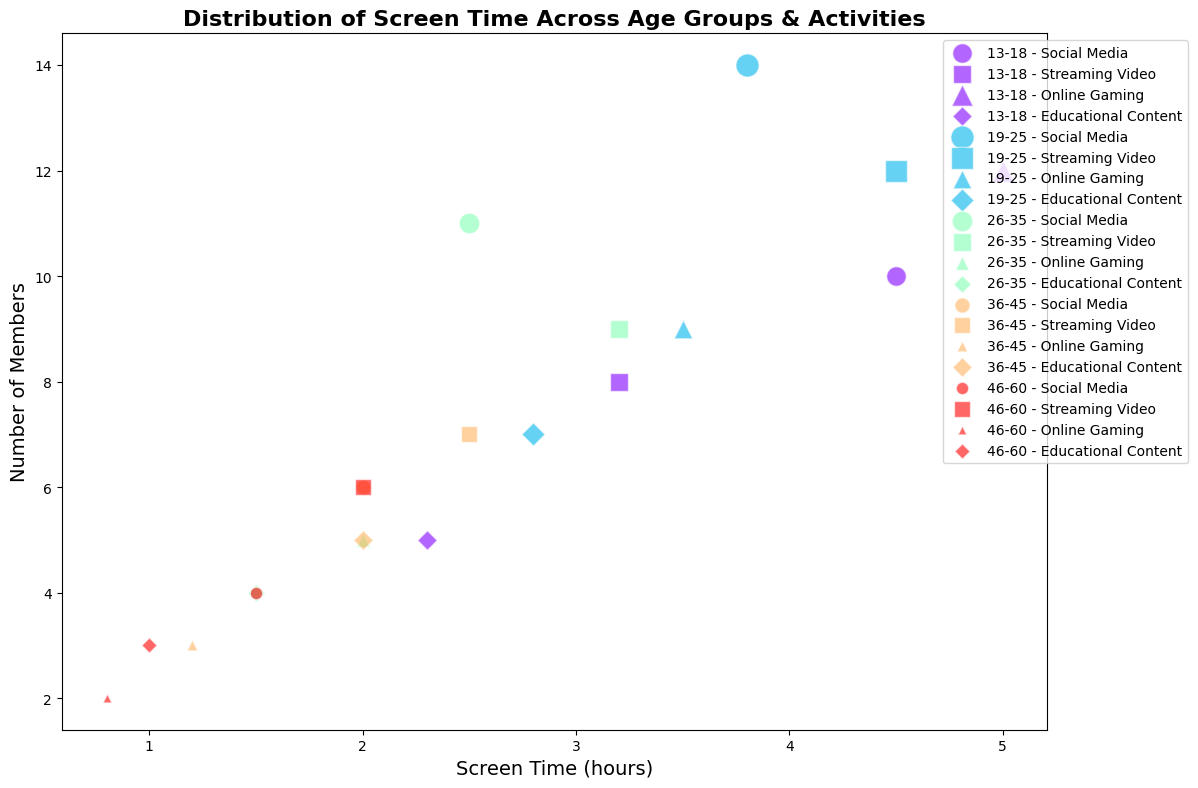What's the average screen time for Online Gaming across all age groups? To calculate the average screen time, sum the screen times for Online Gaming in each age group (5.0 + 3.5 + 2.0 + 1.2 + 0.8) and divide by the number of groups (5). This gives (5.0 + 3.5 + 2.0 + 1.2 + 0.8) / 5 = 12.5 / 5 = 2.5 hours.
Answer: 2.5 hours Which age group has the highest number of members engaged in Social Media? Compare the sizes of bubbles representing Social Media across all age groups. The 19-25 age group has the largest bubble, indicating the highest number of members (14).
Answer: 19-25 Is the screen time for Educational Content higher for the 13-18 age group or the 26-35 age group? Compare the position of the bubbles on the x-axis for Educational Content between the 13-18 and 26-35 age groups. The 13-18 age group has a bubble positioned at 2.3 hours, while the 26-35 age group has a bubble at 1.5 hours.
Answer: 13-18 Which activity has the greatest screen time for the 46-60 age group? Check the x-axis positions of all activities for the 46-60 age group. Streaming Video has the highest value at 2.0 hours.
Answer: Streaming Video In the 36-45 age group, how much greater is the screen time for Streaming Video compared to Online Gaming? Calculate the difference between the screen times for Streaming Video (2.5 hours) and Online Gaming (1.2 hours) for the 36-45 age group. The difference is 2.5 - 1.2 = 1.3 hours.
Answer: 1.3 hours 